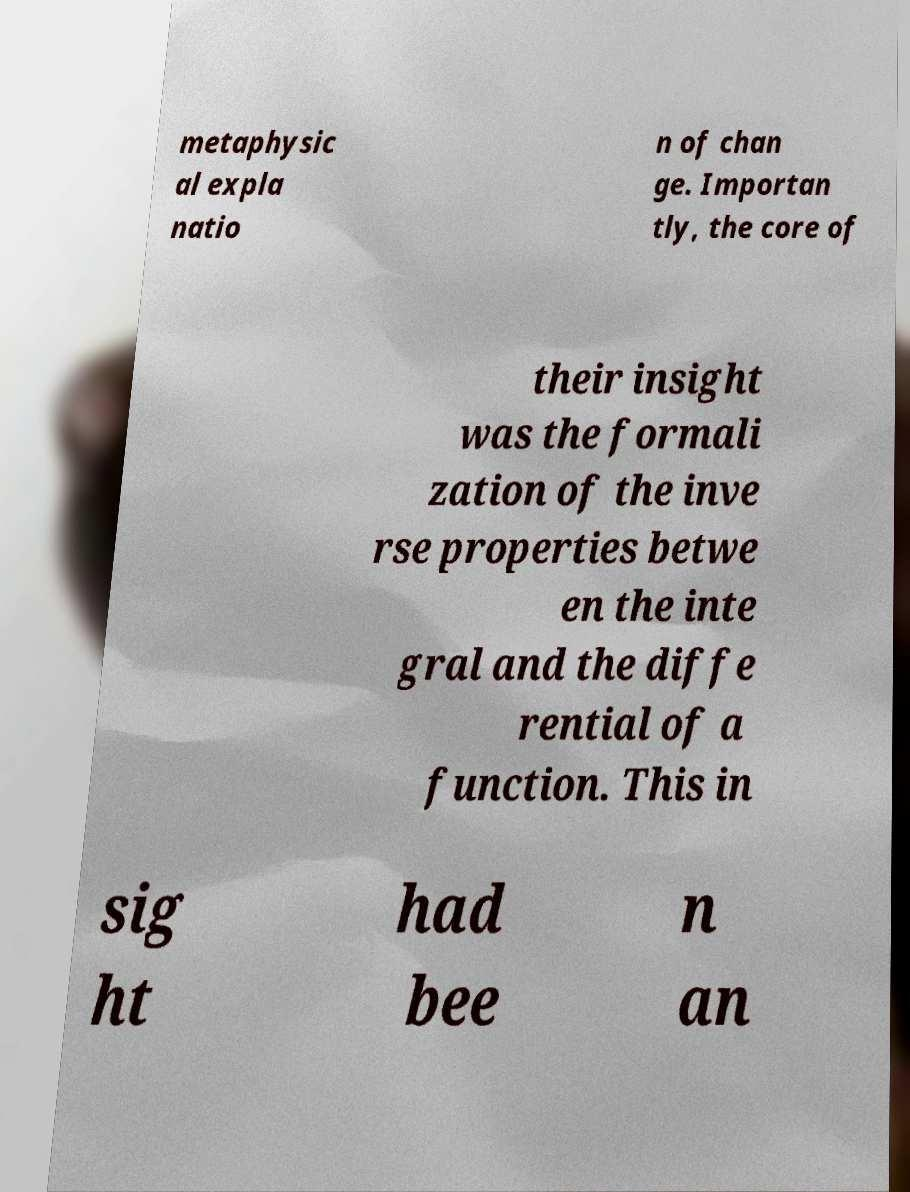What messages or text are displayed in this image? I need them in a readable, typed format. metaphysic al expla natio n of chan ge. Importan tly, the core of their insight was the formali zation of the inve rse properties betwe en the inte gral and the diffe rential of a function. This in sig ht had bee n an 